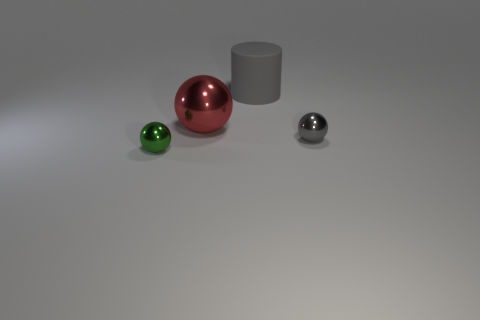What number of other things are there of the same color as the big sphere?
Make the answer very short. 0. The big gray object is what shape?
Provide a short and direct response. Cylinder. There is a small thing that is right of the small shiny ball in front of the small gray shiny thing; what color is it?
Provide a short and direct response. Gray. There is a big matte object; is its color the same as the tiny ball that is on the right side of the large red shiny object?
Provide a succinct answer. Yes. What is the material of the ball that is in front of the red object and on the left side of the gray ball?
Your answer should be compact. Metal. Is there a gray sphere that has the same size as the red object?
Offer a terse response. No. What material is the red ball that is the same size as the matte object?
Your answer should be compact. Metal. There is a red object; what number of tiny green things are behind it?
Provide a succinct answer. 0. Does the metallic thing that is behind the gray sphere have the same shape as the big gray matte object?
Ensure brevity in your answer.  No. Is there another large metallic object of the same shape as the red object?
Your response must be concise. No. 